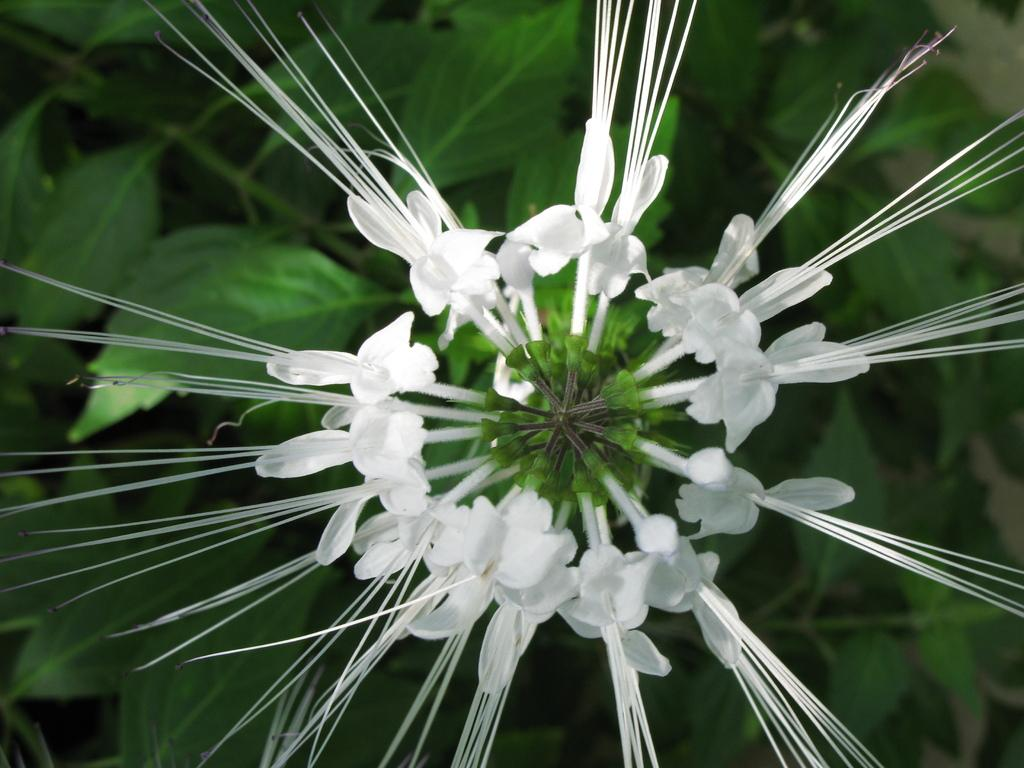What is the focus of the image? The image is zoomed in on a white color flower. Can you describe the flower in the center of the image? The flower is white in color. What else can be seen in the background of the image? There are leaves of a plant visible in the background of the image. What type of brass instrument can be heard playing in the background of the image? There is no brass instrument or sound present in the image, as it is a still photograph of a flower and leaves. 